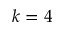<formula> <loc_0><loc_0><loc_500><loc_500>k = 4</formula> 